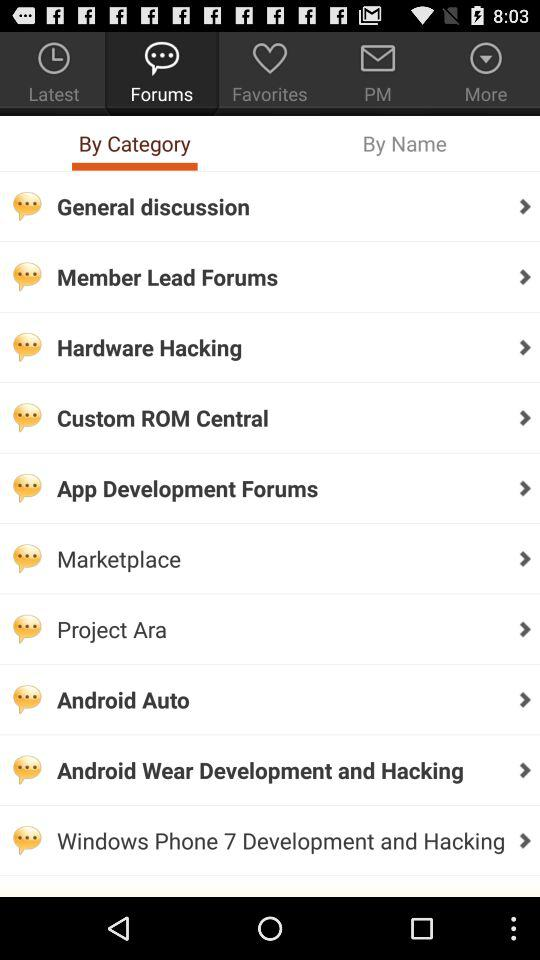Which tab is currently selected under "Forums"? The currently selected tab under "Forums" is "By Category". 